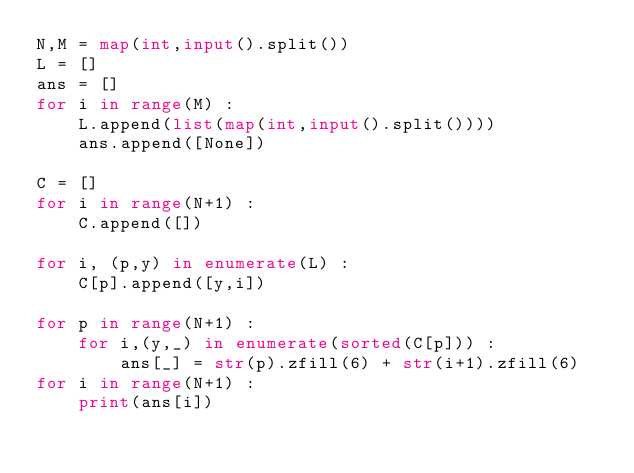<code> <loc_0><loc_0><loc_500><loc_500><_Python_>N,M = map(int,input().split())
L = []
ans = []
for i in range(M) :
    L.append(list(map(int,input().split())))
    ans.append([None])

C = []
for i in range(N+1) :
    C.append([])

for i, (p,y) in enumerate(L) :
    C[p].append([y,i])

for p in range(N+1) :
    for i,(y,_) in enumerate(sorted(C[p])) :
        ans[_] = str(p).zfill(6) + str(i+1).zfill(6)
for i in range(N+1) :
    print(ans[i])
</code> 